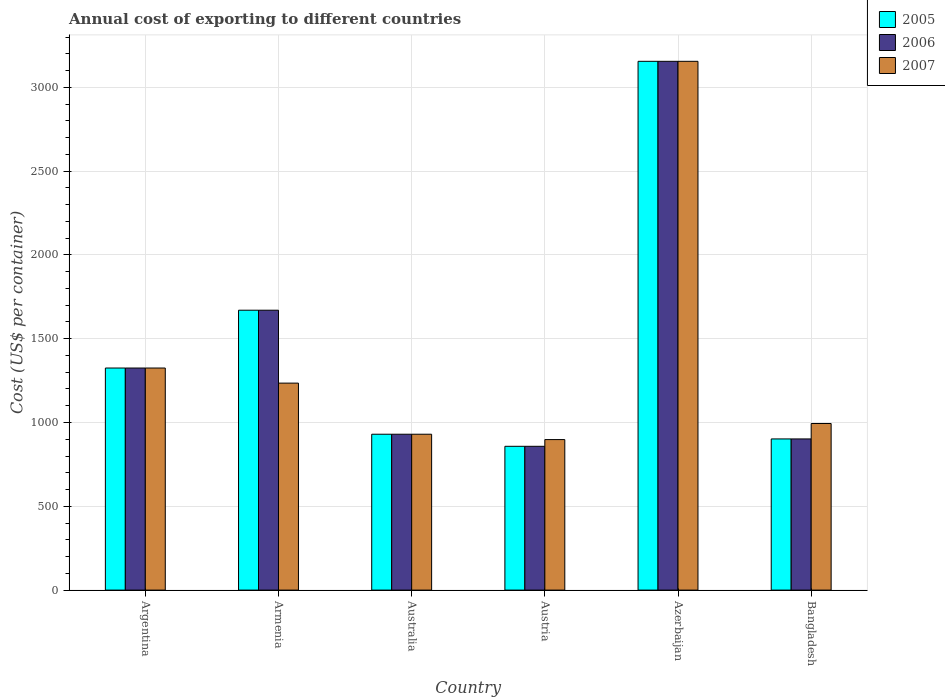How many different coloured bars are there?
Keep it short and to the point. 3. How many groups of bars are there?
Provide a short and direct response. 6. Are the number of bars on each tick of the X-axis equal?
Provide a short and direct response. Yes. How many bars are there on the 2nd tick from the left?
Keep it short and to the point. 3. How many bars are there on the 4th tick from the right?
Offer a very short reply. 3. In how many cases, is the number of bars for a given country not equal to the number of legend labels?
Your answer should be very brief. 0. What is the total annual cost of exporting in 2007 in Argentina?
Your response must be concise. 1325. Across all countries, what is the maximum total annual cost of exporting in 2005?
Provide a succinct answer. 3155. Across all countries, what is the minimum total annual cost of exporting in 2006?
Keep it short and to the point. 858. In which country was the total annual cost of exporting in 2007 maximum?
Make the answer very short. Azerbaijan. What is the total total annual cost of exporting in 2005 in the graph?
Give a very brief answer. 8840. What is the difference between the total annual cost of exporting in 2007 in Argentina and that in Australia?
Your answer should be compact. 395. What is the difference between the total annual cost of exporting in 2007 in Australia and the total annual cost of exporting in 2005 in Armenia?
Your answer should be very brief. -740. What is the average total annual cost of exporting in 2005 per country?
Your response must be concise. 1473.33. What is the difference between the total annual cost of exporting of/in 2006 and total annual cost of exporting of/in 2007 in Bangladesh?
Offer a very short reply. -92. In how many countries, is the total annual cost of exporting in 2005 greater than 200 US$?
Offer a terse response. 6. What is the ratio of the total annual cost of exporting in 2007 in Australia to that in Austria?
Offer a very short reply. 1.04. Is the difference between the total annual cost of exporting in 2006 in Australia and Azerbaijan greater than the difference between the total annual cost of exporting in 2007 in Australia and Azerbaijan?
Your answer should be very brief. No. What is the difference between the highest and the second highest total annual cost of exporting in 2006?
Your answer should be compact. 1830. What is the difference between the highest and the lowest total annual cost of exporting in 2007?
Offer a terse response. 2257. In how many countries, is the total annual cost of exporting in 2007 greater than the average total annual cost of exporting in 2007 taken over all countries?
Offer a very short reply. 1. Is the sum of the total annual cost of exporting in 2005 in Argentina and Australia greater than the maximum total annual cost of exporting in 2007 across all countries?
Make the answer very short. No. What does the 2nd bar from the left in Azerbaijan represents?
Keep it short and to the point. 2006. Is it the case that in every country, the sum of the total annual cost of exporting in 2007 and total annual cost of exporting in 2005 is greater than the total annual cost of exporting in 2006?
Provide a short and direct response. Yes. Are all the bars in the graph horizontal?
Your response must be concise. No. How many countries are there in the graph?
Keep it short and to the point. 6. What is the difference between two consecutive major ticks on the Y-axis?
Your answer should be very brief. 500. Are the values on the major ticks of Y-axis written in scientific E-notation?
Provide a succinct answer. No. What is the title of the graph?
Offer a terse response. Annual cost of exporting to different countries. What is the label or title of the Y-axis?
Ensure brevity in your answer.  Cost (US$ per container). What is the Cost (US$ per container) of 2005 in Argentina?
Give a very brief answer. 1325. What is the Cost (US$ per container) in 2006 in Argentina?
Your answer should be compact. 1325. What is the Cost (US$ per container) of 2007 in Argentina?
Provide a short and direct response. 1325. What is the Cost (US$ per container) in 2005 in Armenia?
Your response must be concise. 1670. What is the Cost (US$ per container) in 2006 in Armenia?
Offer a very short reply. 1670. What is the Cost (US$ per container) of 2007 in Armenia?
Provide a succinct answer. 1235. What is the Cost (US$ per container) of 2005 in Australia?
Offer a very short reply. 930. What is the Cost (US$ per container) of 2006 in Australia?
Give a very brief answer. 930. What is the Cost (US$ per container) of 2007 in Australia?
Make the answer very short. 930. What is the Cost (US$ per container) in 2005 in Austria?
Your answer should be very brief. 858. What is the Cost (US$ per container) of 2006 in Austria?
Offer a very short reply. 858. What is the Cost (US$ per container) in 2007 in Austria?
Your answer should be compact. 898. What is the Cost (US$ per container) in 2005 in Azerbaijan?
Offer a terse response. 3155. What is the Cost (US$ per container) in 2006 in Azerbaijan?
Offer a terse response. 3155. What is the Cost (US$ per container) of 2007 in Azerbaijan?
Keep it short and to the point. 3155. What is the Cost (US$ per container) in 2005 in Bangladesh?
Provide a short and direct response. 902. What is the Cost (US$ per container) in 2006 in Bangladesh?
Give a very brief answer. 902. What is the Cost (US$ per container) in 2007 in Bangladesh?
Make the answer very short. 994. Across all countries, what is the maximum Cost (US$ per container) in 2005?
Offer a terse response. 3155. Across all countries, what is the maximum Cost (US$ per container) of 2006?
Offer a terse response. 3155. Across all countries, what is the maximum Cost (US$ per container) in 2007?
Provide a succinct answer. 3155. Across all countries, what is the minimum Cost (US$ per container) of 2005?
Ensure brevity in your answer.  858. Across all countries, what is the minimum Cost (US$ per container) of 2006?
Make the answer very short. 858. Across all countries, what is the minimum Cost (US$ per container) of 2007?
Provide a succinct answer. 898. What is the total Cost (US$ per container) in 2005 in the graph?
Provide a succinct answer. 8840. What is the total Cost (US$ per container) of 2006 in the graph?
Make the answer very short. 8840. What is the total Cost (US$ per container) in 2007 in the graph?
Ensure brevity in your answer.  8537. What is the difference between the Cost (US$ per container) of 2005 in Argentina and that in Armenia?
Give a very brief answer. -345. What is the difference between the Cost (US$ per container) in 2006 in Argentina and that in Armenia?
Your response must be concise. -345. What is the difference between the Cost (US$ per container) in 2005 in Argentina and that in Australia?
Your response must be concise. 395. What is the difference between the Cost (US$ per container) in 2006 in Argentina and that in Australia?
Provide a succinct answer. 395. What is the difference between the Cost (US$ per container) in 2007 in Argentina and that in Australia?
Offer a terse response. 395. What is the difference between the Cost (US$ per container) of 2005 in Argentina and that in Austria?
Provide a succinct answer. 467. What is the difference between the Cost (US$ per container) in 2006 in Argentina and that in Austria?
Offer a terse response. 467. What is the difference between the Cost (US$ per container) of 2007 in Argentina and that in Austria?
Provide a short and direct response. 427. What is the difference between the Cost (US$ per container) in 2005 in Argentina and that in Azerbaijan?
Make the answer very short. -1830. What is the difference between the Cost (US$ per container) in 2006 in Argentina and that in Azerbaijan?
Your response must be concise. -1830. What is the difference between the Cost (US$ per container) of 2007 in Argentina and that in Azerbaijan?
Give a very brief answer. -1830. What is the difference between the Cost (US$ per container) of 2005 in Argentina and that in Bangladesh?
Offer a terse response. 423. What is the difference between the Cost (US$ per container) in 2006 in Argentina and that in Bangladesh?
Offer a very short reply. 423. What is the difference between the Cost (US$ per container) in 2007 in Argentina and that in Bangladesh?
Your answer should be very brief. 331. What is the difference between the Cost (US$ per container) in 2005 in Armenia and that in Australia?
Provide a succinct answer. 740. What is the difference between the Cost (US$ per container) in 2006 in Armenia and that in Australia?
Make the answer very short. 740. What is the difference between the Cost (US$ per container) of 2007 in Armenia and that in Australia?
Offer a terse response. 305. What is the difference between the Cost (US$ per container) in 2005 in Armenia and that in Austria?
Your response must be concise. 812. What is the difference between the Cost (US$ per container) in 2006 in Armenia and that in Austria?
Ensure brevity in your answer.  812. What is the difference between the Cost (US$ per container) of 2007 in Armenia and that in Austria?
Your response must be concise. 337. What is the difference between the Cost (US$ per container) of 2005 in Armenia and that in Azerbaijan?
Offer a very short reply. -1485. What is the difference between the Cost (US$ per container) of 2006 in Armenia and that in Azerbaijan?
Offer a terse response. -1485. What is the difference between the Cost (US$ per container) of 2007 in Armenia and that in Azerbaijan?
Make the answer very short. -1920. What is the difference between the Cost (US$ per container) in 2005 in Armenia and that in Bangladesh?
Give a very brief answer. 768. What is the difference between the Cost (US$ per container) in 2006 in Armenia and that in Bangladesh?
Your answer should be compact. 768. What is the difference between the Cost (US$ per container) in 2007 in Armenia and that in Bangladesh?
Ensure brevity in your answer.  241. What is the difference between the Cost (US$ per container) in 2006 in Australia and that in Austria?
Offer a very short reply. 72. What is the difference between the Cost (US$ per container) of 2007 in Australia and that in Austria?
Your response must be concise. 32. What is the difference between the Cost (US$ per container) of 2005 in Australia and that in Azerbaijan?
Make the answer very short. -2225. What is the difference between the Cost (US$ per container) of 2006 in Australia and that in Azerbaijan?
Offer a very short reply. -2225. What is the difference between the Cost (US$ per container) of 2007 in Australia and that in Azerbaijan?
Your response must be concise. -2225. What is the difference between the Cost (US$ per container) of 2005 in Australia and that in Bangladesh?
Give a very brief answer. 28. What is the difference between the Cost (US$ per container) of 2007 in Australia and that in Bangladesh?
Offer a very short reply. -64. What is the difference between the Cost (US$ per container) of 2005 in Austria and that in Azerbaijan?
Keep it short and to the point. -2297. What is the difference between the Cost (US$ per container) of 2006 in Austria and that in Azerbaijan?
Provide a short and direct response. -2297. What is the difference between the Cost (US$ per container) of 2007 in Austria and that in Azerbaijan?
Your answer should be very brief. -2257. What is the difference between the Cost (US$ per container) of 2005 in Austria and that in Bangladesh?
Your answer should be compact. -44. What is the difference between the Cost (US$ per container) in 2006 in Austria and that in Bangladesh?
Your answer should be very brief. -44. What is the difference between the Cost (US$ per container) of 2007 in Austria and that in Bangladesh?
Your answer should be compact. -96. What is the difference between the Cost (US$ per container) in 2005 in Azerbaijan and that in Bangladesh?
Your answer should be compact. 2253. What is the difference between the Cost (US$ per container) of 2006 in Azerbaijan and that in Bangladesh?
Offer a very short reply. 2253. What is the difference between the Cost (US$ per container) of 2007 in Azerbaijan and that in Bangladesh?
Offer a terse response. 2161. What is the difference between the Cost (US$ per container) in 2005 in Argentina and the Cost (US$ per container) in 2006 in Armenia?
Give a very brief answer. -345. What is the difference between the Cost (US$ per container) of 2005 in Argentina and the Cost (US$ per container) of 2007 in Armenia?
Make the answer very short. 90. What is the difference between the Cost (US$ per container) of 2006 in Argentina and the Cost (US$ per container) of 2007 in Armenia?
Your response must be concise. 90. What is the difference between the Cost (US$ per container) of 2005 in Argentina and the Cost (US$ per container) of 2006 in Australia?
Your answer should be compact. 395. What is the difference between the Cost (US$ per container) of 2005 in Argentina and the Cost (US$ per container) of 2007 in Australia?
Keep it short and to the point. 395. What is the difference between the Cost (US$ per container) of 2006 in Argentina and the Cost (US$ per container) of 2007 in Australia?
Provide a short and direct response. 395. What is the difference between the Cost (US$ per container) in 2005 in Argentina and the Cost (US$ per container) in 2006 in Austria?
Your answer should be very brief. 467. What is the difference between the Cost (US$ per container) in 2005 in Argentina and the Cost (US$ per container) in 2007 in Austria?
Your answer should be very brief. 427. What is the difference between the Cost (US$ per container) of 2006 in Argentina and the Cost (US$ per container) of 2007 in Austria?
Offer a very short reply. 427. What is the difference between the Cost (US$ per container) in 2005 in Argentina and the Cost (US$ per container) in 2006 in Azerbaijan?
Make the answer very short. -1830. What is the difference between the Cost (US$ per container) of 2005 in Argentina and the Cost (US$ per container) of 2007 in Azerbaijan?
Make the answer very short. -1830. What is the difference between the Cost (US$ per container) in 2006 in Argentina and the Cost (US$ per container) in 2007 in Azerbaijan?
Your answer should be compact. -1830. What is the difference between the Cost (US$ per container) in 2005 in Argentina and the Cost (US$ per container) in 2006 in Bangladesh?
Your answer should be compact. 423. What is the difference between the Cost (US$ per container) in 2005 in Argentina and the Cost (US$ per container) in 2007 in Bangladesh?
Your answer should be very brief. 331. What is the difference between the Cost (US$ per container) of 2006 in Argentina and the Cost (US$ per container) of 2007 in Bangladesh?
Ensure brevity in your answer.  331. What is the difference between the Cost (US$ per container) of 2005 in Armenia and the Cost (US$ per container) of 2006 in Australia?
Provide a succinct answer. 740. What is the difference between the Cost (US$ per container) in 2005 in Armenia and the Cost (US$ per container) in 2007 in Australia?
Ensure brevity in your answer.  740. What is the difference between the Cost (US$ per container) in 2006 in Armenia and the Cost (US$ per container) in 2007 in Australia?
Ensure brevity in your answer.  740. What is the difference between the Cost (US$ per container) of 2005 in Armenia and the Cost (US$ per container) of 2006 in Austria?
Provide a succinct answer. 812. What is the difference between the Cost (US$ per container) of 2005 in Armenia and the Cost (US$ per container) of 2007 in Austria?
Give a very brief answer. 772. What is the difference between the Cost (US$ per container) in 2006 in Armenia and the Cost (US$ per container) in 2007 in Austria?
Offer a terse response. 772. What is the difference between the Cost (US$ per container) of 2005 in Armenia and the Cost (US$ per container) of 2006 in Azerbaijan?
Offer a terse response. -1485. What is the difference between the Cost (US$ per container) of 2005 in Armenia and the Cost (US$ per container) of 2007 in Azerbaijan?
Make the answer very short. -1485. What is the difference between the Cost (US$ per container) in 2006 in Armenia and the Cost (US$ per container) in 2007 in Azerbaijan?
Provide a succinct answer. -1485. What is the difference between the Cost (US$ per container) in 2005 in Armenia and the Cost (US$ per container) in 2006 in Bangladesh?
Give a very brief answer. 768. What is the difference between the Cost (US$ per container) in 2005 in Armenia and the Cost (US$ per container) in 2007 in Bangladesh?
Provide a succinct answer. 676. What is the difference between the Cost (US$ per container) of 2006 in Armenia and the Cost (US$ per container) of 2007 in Bangladesh?
Ensure brevity in your answer.  676. What is the difference between the Cost (US$ per container) of 2005 in Australia and the Cost (US$ per container) of 2007 in Austria?
Give a very brief answer. 32. What is the difference between the Cost (US$ per container) in 2005 in Australia and the Cost (US$ per container) in 2006 in Azerbaijan?
Keep it short and to the point. -2225. What is the difference between the Cost (US$ per container) of 2005 in Australia and the Cost (US$ per container) of 2007 in Azerbaijan?
Give a very brief answer. -2225. What is the difference between the Cost (US$ per container) of 2006 in Australia and the Cost (US$ per container) of 2007 in Azerbaijan?
Your answer should be compact. -2225. What is the difference between the Cost (US$ per container) of 2005 in Australia and the Cost (US$ per container) of 2007 in Bangladesh?
Your answer should be very brief. -64. What is the difference between the Cost (US$ per container) of 2006 in Australia and the Cost (US$ per container) of 2007 in Bangladesh?
Give a very brief answer. -64. What is the difference between the Cost (US$ per container) in 2005 in Austria and the Cost (US$ per container) in 2006 in Azerbaijan?
Provide a succinct answer. -2297. What is the difference between the Cost (US$ per container) in 2005 in Austria and the Cost (US$ per container) in 2007 in Azerbaijan?
Your answer should be very brief. -2297. What is the difference between the Cost (US$ per container) of 2006 in Austria and the Cost (US$ per container) of 2007 in Azerbaijan?
Your answer should be compact. -2297. What is the difference between the Cost (US$ per container) in 2005 in Austria and the Cost (US$ per container) in 2006 in Bangladesh?
Give a very brief answer. -44. What is the difference between the Cost (US$ per container) in 2005 in Austria and the Cost (US$ per container) in 2007 in Bangladesh?
Offer a very short reply. -136. What is the difference between the Cost (US$ per container) of 2006 in Austria and the Cost (US$ per container) of 2007 in Bangladesh?
Your answer should be compact. -136. What is the difference between the Cost (US$ per container) in 2005 in Azerbaijan and the Cost (US$ per container) in 2006 in Bangladesh?
Offer a very short reply. 2253. What is the difference between the Cost (US$ per container) in 2005 in Azerbaijan and the Cost (US$ per container) in 2007 in Bangladesh?
Provide a succinct answer. 2161. What is the difference between the Cost (US$ per container) of 2006 in Azerbaijan and the Cost (US$ per container) of 2007 in Bangladesh?
Provide a short and direct response. 2161. What is the average Cost (US$ per container) in 2005 per country?
Your answer should be very brief. 1473.33. What is the average Cost (US$ per container) of 2006 per country?
Give a very brief answer. 1473.33. What is the average Cost (US$ per container) in 2007 per country?
Provide a succinct answer. 1422.83. What is the difference between the Cost (US$ per container) of 2005 and Cost (US$ per container) of 2007 in Argentina?
Provide a short and direct response. 0. What is the difference between the Cost (US$ per container) in 2005 and Cost (US$ per container) in 2006 in Armenia?
Your answer should be compact. 0. What is the difference between the Cost (US$ per container) in 2005 and Cost (US$ per container) in 2007 in Armenia?
Ensure brevity in your answer.  435. What is the difference between the Cost (US$ per container) of 2006 and Cost (US$ per container) of 2007 in Armenia?
Your answer should be very brief. 435. What is the difference between the Cost (US$ per container) in 2006 and Cost (US$ per container) in 2007 in Australia?
Offer a very short reply. 0. What is the difference between the Cost (US$ per container) in 2005 and Cost (US$ per container) in 2007 in Austria?
Your answer should be very brief. -40. What is the difference between the Cost (US$ per container) of 2005 and Cost (US$ per container) of 2006 in Azerbaijan?
Provide a short and direct response. 0. What is the difference between the Cost (US$ per container) of 2005 and Cost (US$ per container) of 2007 in Azerbaijan?
Your answer should be compact. 0. What is the difference between the Cost (US$ per container) of 2006 and Cost (US$ per container) of 2007 in Azerbaijan?
Your answer should be very brief. 0. What is the difference between the Cost (US$ per container) in 2005 and Cost (US$ per container) in 2006 in Bangladesh?
Your answer should be very brief. 0. What is the difference between the Cost (US$ per container) of 2005 and Cost (US$ per container) of 2007 in Bangladesh?
Give a very brief answer. -92. What is the difference between the Cost (US$ per container) of 2006 and Cost (US$ per container) of 2007 in Bangladesh?
Give a very brief answer. -92. What is the ratio of the Cost (US$ per container) in 2005 in Argentina to that in Armenia?
Make the answer very short. 0.79. What is the ratio of the Cost (US$ per container) in 2006 in Argentina to that in Armenia?
Your answer should be very brief. 0.79. What is the ratio of the Cost (US$ per container) in 2007 in Argentina to that in Armenia?
Your answer should be very brief. 1.07. What is the ratio of the Cost (US$ per container) of 2005 in Argentina to that in Australia?
Give a very brief answer. 1.42. What is the ratio of the Cost (US$ per container) in 2006 in Argentina to that in Australia?
Your response must be concise. 1.42. What is the ratio of the Cost (US$ per container) in 2007 in Argentina to that in Australia?
Keep it short and to the point. 1.42. What is the ratio of the Cost (US$ per container) of 2005 in Argentina to that in Austria?
Give a very brief answer. 1.54. What is the ratio of the Cost (US$ per container) in 2006 in Argentina to that in Austria?
Provide a succinct answer. 1.54. What is the ratio of the Cost (US$ per container) of 2007 in Argentina to that in Austria?
Provide a short and direct response. 1.48. What is the ratio of the Cost (US$ per container) in 2005 in Argentina to that in Azerbaijan?
Keep it short and to the point. 0.42. What is the ratio of the Cost (US$ per container) of 2006 in Argentina to that in Azerbaijan?
Ensure brevity in your answer.  0.42. What is the ratio of the Cost (US$ per container) in 2007 in Argentina to that in Azerbaijan?
Keep it short and to the point. 0.42. What is the ratio of the Cost (US$ per container) of 2005 in Argentina to that in Bangladesh?
Your answer should be very brief. 1.47. What is the ratio of the Cost (US$ per container) of 2006 in Argentina to that in Bangladesh?
Offer a terse response. 1.47. What is the ratio of the Cost (US$ per container) of 2007 in Argentina to that in Bangladesh?
Your response must be concise. 1.33. What is the ratio of the Cost (US$ per container) in 2005 in Armenia to that in Australia?
Offer a terse response. 1.8. What is the ratio of the Cost (US$ per container) in 2006 in Armenia to that in Australia?
Provide a short and direct response. 1.8. What is the ratio of the Cost (US$ per container) in 2007 in Armenia to that in Australia?
Make the answer very short. 1.33. What is the ratio of the Cost (US$ per container) in 2005 in Armenia to that in Austria?
Give a very brief answer. 1.95. What is the ratio of the Cost (US$ per container) of 2006 in Armenia to that in Austria?
Your answer should be very brief. 1.95. What is the ratio of the Cost (US$ per container) of 2007 in Armenia to that in Austria?
Your response must be concise. 1.38. What is the ratio of the Cost (US$ per container) in 2005 in Armenia to that in Azerbaijan?
Keep it short and to the point. 0.53. What is the ratio of the Cost (US$ per container) of 2006 in Armenia to that in Azerbaijan?
Your answer should be very brief. 0.53. What is the ratio of the Cost (US$ per container) in 2007 in Armenia to that in Azerbaijan?
Give a very brief answer. 0.39. What is the ratio of the Cost (US$ per container) in 2005 in Armenia to that in Bangladesh?
Offer a terse response. 1.85. What is the ratio of the Cost (US$ per container) of 2006 in Armenia to that in Bangladesh?
Your response must be concise. 1.85. What is the ratio of the Cost (US$ per container) of 2007 in Armenia to that in Bangladesh?
Provide a succinct answer. 1.24. What is the ratio of the Cost (US$ per container) of 2005 in Australia to that in Austria?
Your response must be concise. 1.08. What is the ratio of the Cost (US$ per container) in 2006 in Australia to that in Austria?
Provide a short and direct response. 1.08. What is the ratio of the Cost (US$ per container) in 2007 in Australia to that in Austria?
Provide a succinct answer. 1.04. What is the ratio of the Cost (US$ per container) of 2005 in Australia to that in Azerbaijan?
Your answer should be very brief. 0.29. What is the ratio of the Cost (US$ per container) in 2006 in Australia to that in Azerbaijan?
Your answer should be very brief. 0.29. What is the ratio of the Cost (US$ per container) of 2007 in Australia to that in Azerbaijan?
Give a very brief answer. 0.29. What is the ratio of the Cost (US$ per container) in 2005 in Australia to that in Bangladesh?
Your answer should be very brief. 1.03. What is the ratio of the Cost (US$ per container) in 2006 in Australia to that in Bangladesh?
Make the answer very short. 1.03. What is the ratio of the Cost (US$ per container) in 2007 in Australia to that in Bangladesh?
Provide a short and direct response. 0.94. What is the ratio of the Cost (US$ per container) of 2005 in Austria to that in Azerbaijan?
Make the answer very short. 0.27. What is the ratio of the Cost (US$ per container) in 2006 in Austria to that in Azerbaijan?
Your answer should be compact. 0.27. What is the ratio of the Cost (US$ per container) in 2007 in Austria to that in Azerbaijan?
Keep it short and to the point. 0.28. What is the ratio of the Cost (US$ per container) of 2005 in Austria to that in Bangladesh?
Offer a terse response. 0.95. What is the ratio of the Cost (US$ per container) of 2006 in Austria to that in Bangladesh?
Provide a short and direct response. 0.95. What is the ratio of the Cost (US$ per container) of 2007 in Austria to that in Bangladesh?
Your response must be concise. 0.9. What is the ratio of the Cost (US$ per container) in 2005 in Azerbaijan to that in Bangladesh?
Make the answer very short. 3.5. What is the ratio of the Cost (US$ per container) in 2006 in Azerbaijan to that in Bangladesh?
Ensure brevity in your answer.  3.5. What is the ratio of the Cost (US$ per container) in 2007 in Azerbaijan to that in Bangladesh?
Keep it short and to the point. 3.17. What is the difference between the highest and the second highest Cost (US$ per container) of 2005?
Provide a short and direct response. 1485. What is the difference between the highest and the second highest Cost (US$ per container) of 2006?
Provide a succinct answer. 1485. What is the difference between the highest and the second highest Cost (US$ per container) in 2007?
Provide a short and direct response. 1830. What is the difference between the highest and the lowest Cost (US$ per container) of 2005?
Provide a short and direct response. 2297. What is the difference between the highest and the lowest Cost (US$ per container) of 2006?
Your answer should be very brief. 2297. What is the difference between the highest and the lowest Cost (US$ per container) of 2007?
Your response must be concise. 2257. 